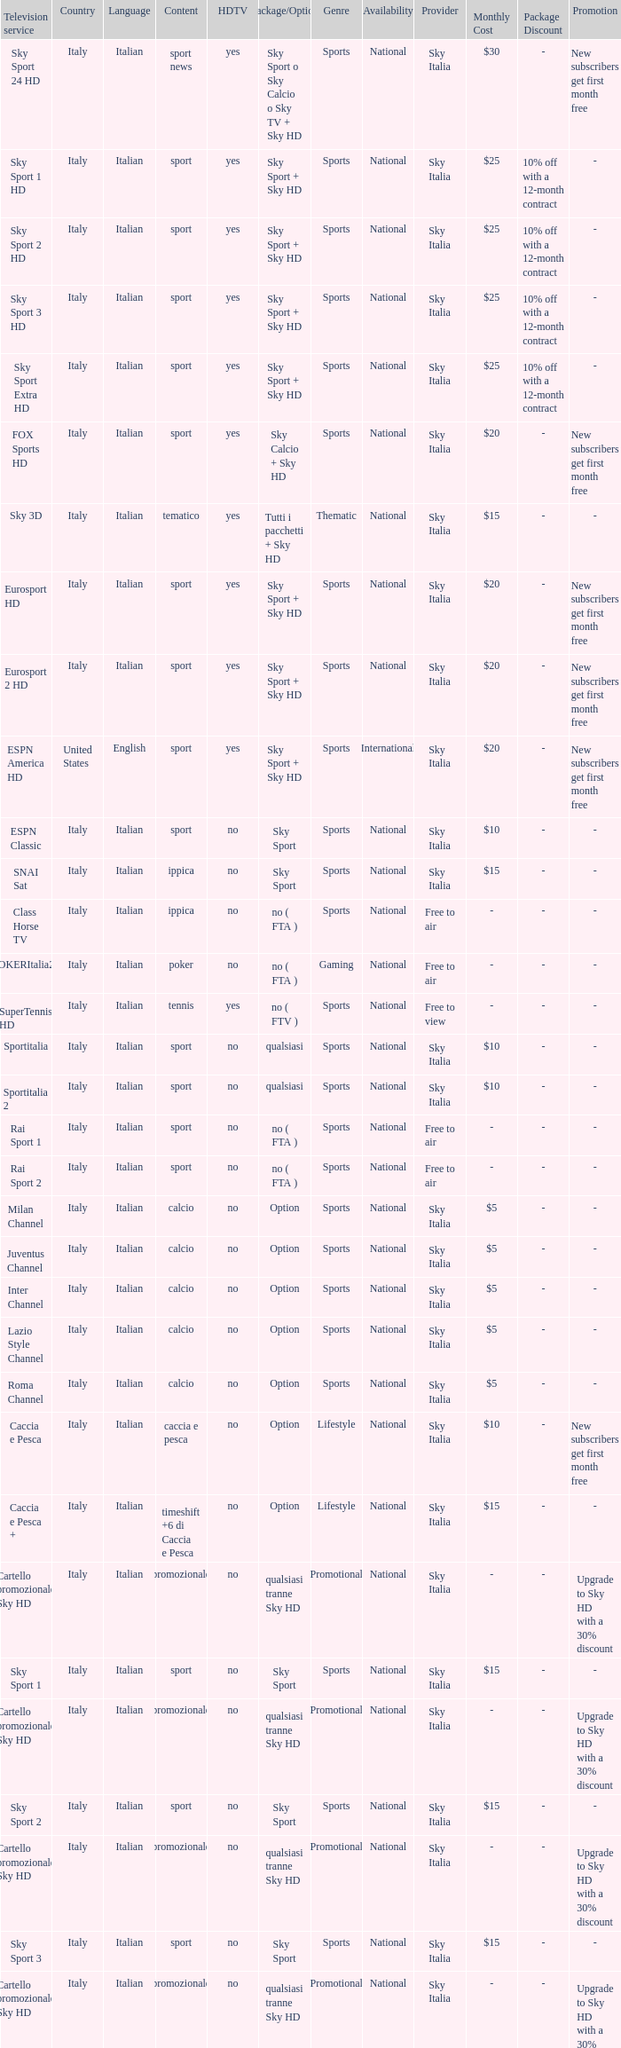What is Television Service, when Content is Calcio, and when Package/Option is Option? Milan Channel, Juventus Channel, Inter Channel, Lazio Style Channel, Roma Channel. 